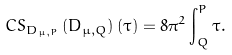Convert formula to latex. <formula><loc_0><loc_0><loc_500><loc_500>C S _ { D _ { \mu , P } } \left ( D _ { \mu , Q } \right ) \left ( \tau \right ) = 8 \pi ^ { 2 } \int \nolimits _ { Q } ^ { P } \tau .</formula> 